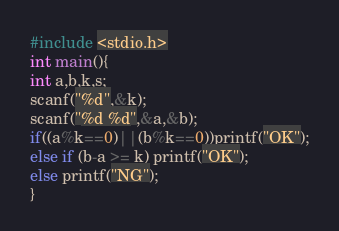<code> <loc_0><loc_0><loc_500><loc_500><_C_>#include <stdio.h>
int main(){
int a,b,k,s;
scanf("%d",&k);
scanf("%d %d",&a,&b);
if((a%k==0)||(b%k==0))printf("OK");
else if (b-a >= k) printf("OK");
else printf("NG");
}</code> 